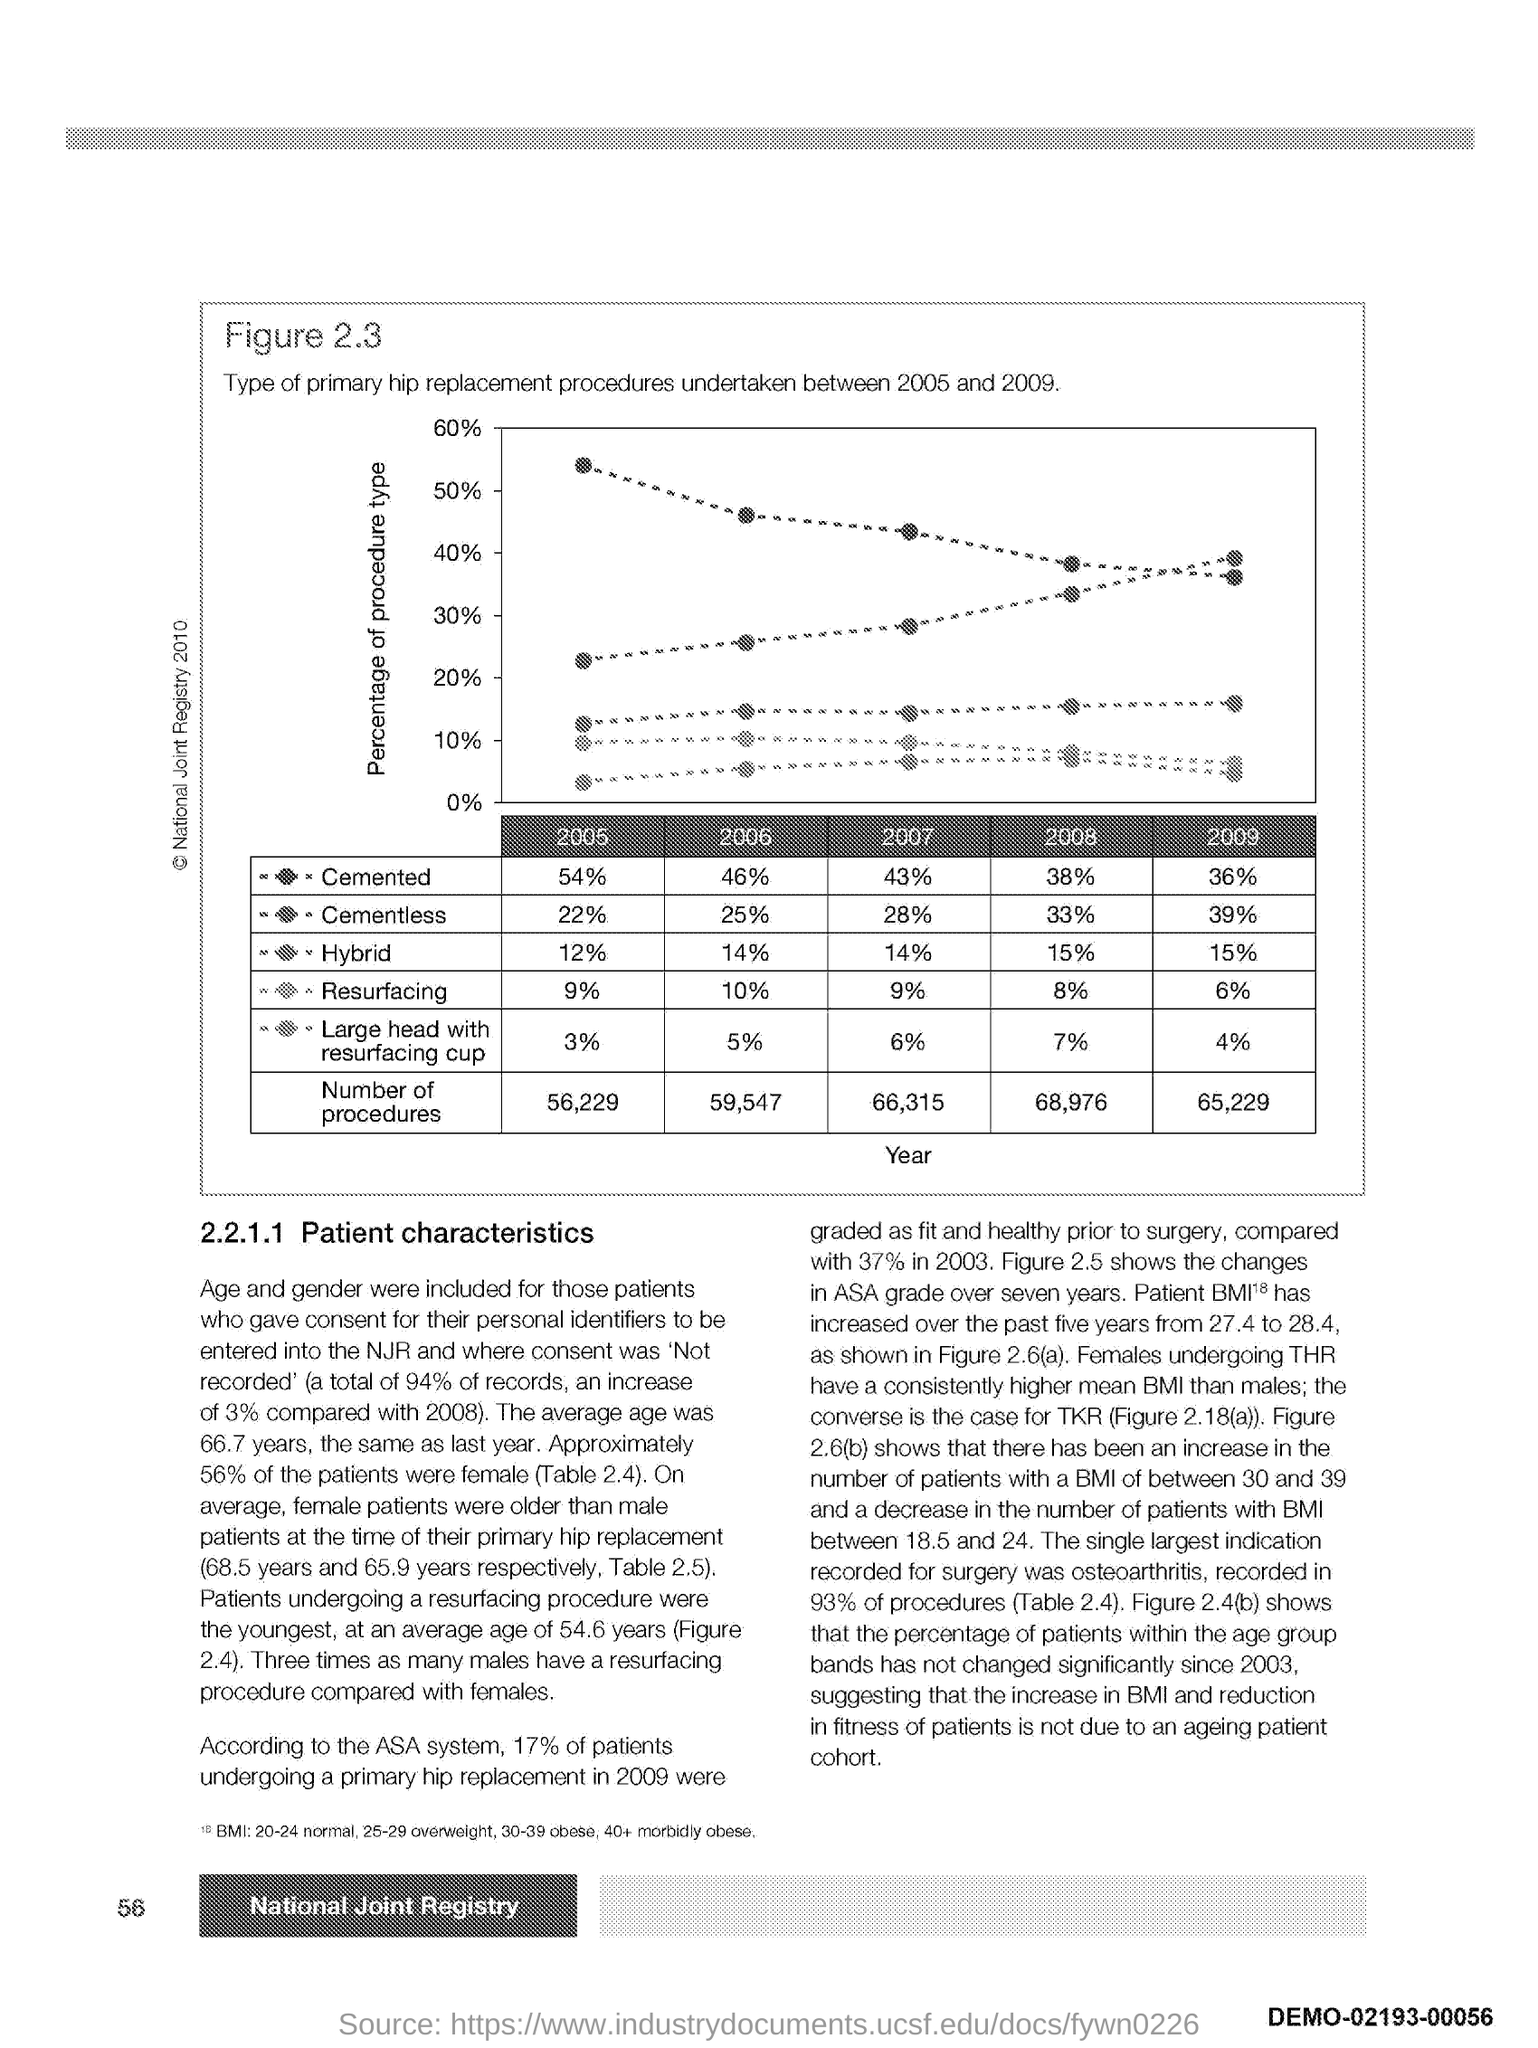What is the number at bottom left side of the page ?
Provide a short and direct response. 56. What is the heading of the paragraph?
Keep it short and to the point. Patient characteristics. 